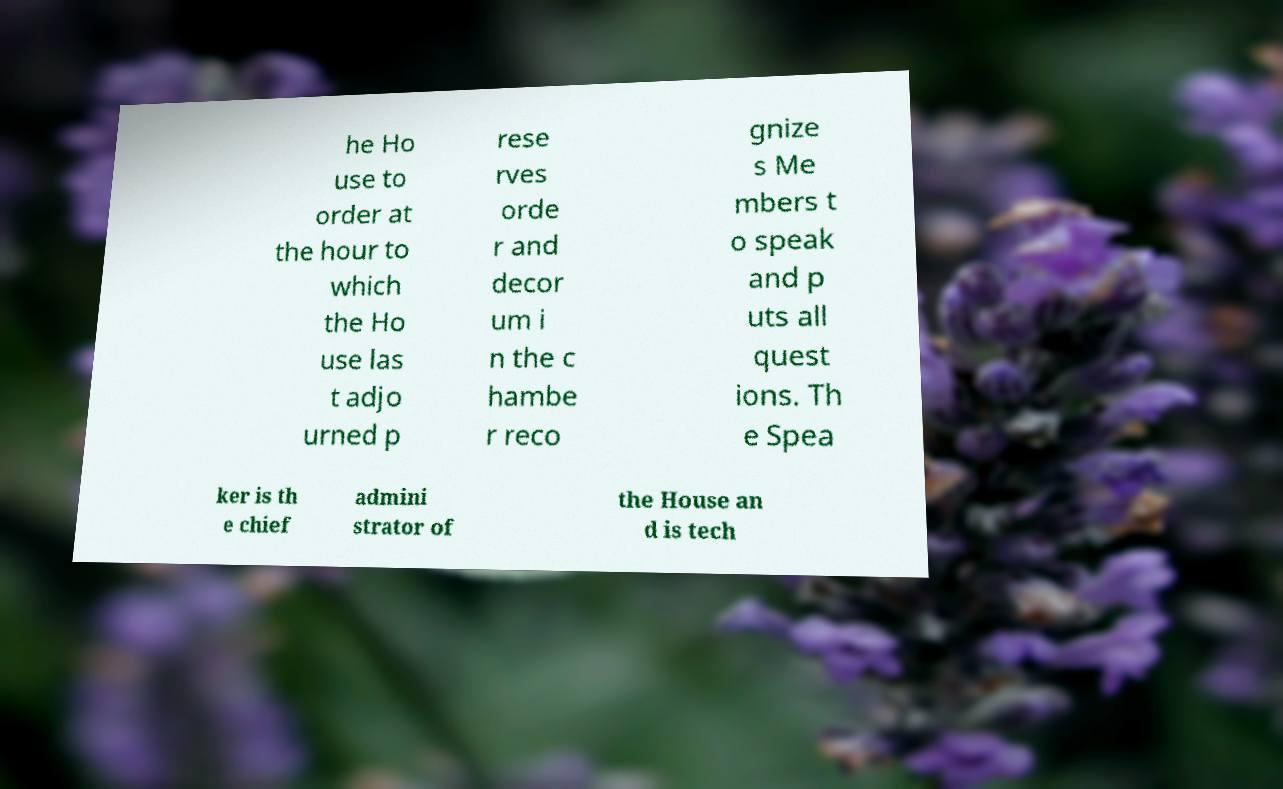Could you extract and type out the text from this image? he Ho use to order at the hour to which the Ho use las t adjo urned p rese rves orde r and decor um i n the c hambe r reco gnize s Me mbers t o speak and p uts all quest ions. Th e Spea ker is th e chief admini strator of the House an d is tech 